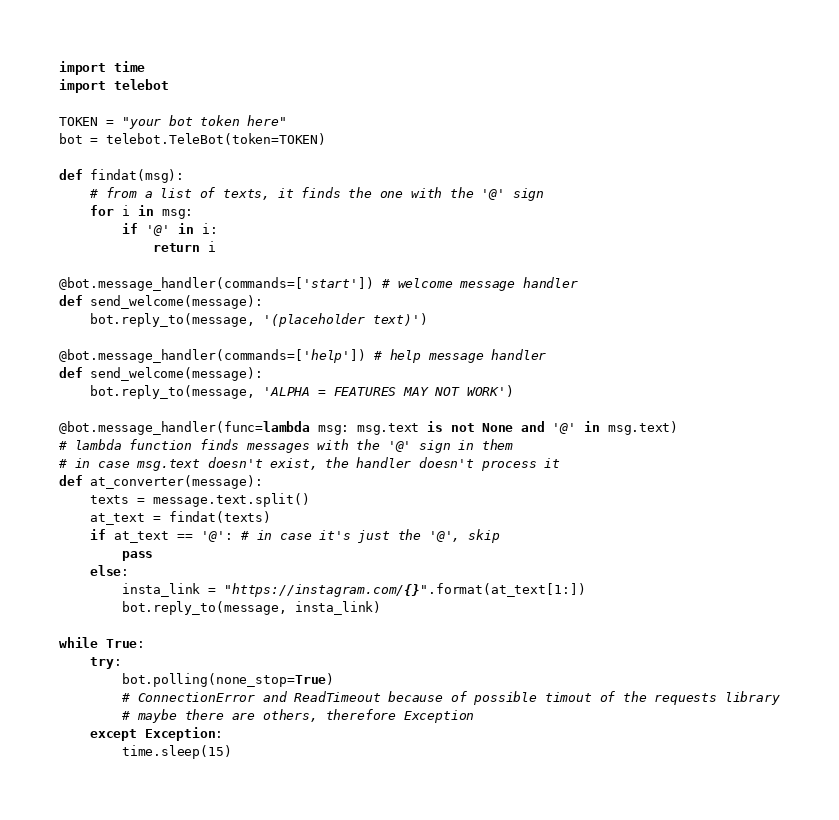<code> <loc_0><loc_0><loc_500><loc_500><_Python_>import time
import telebot

TOKEN = "your bot token here"
bot = telebot.TeleBot(token=TOKEN)

def findat(msg):
    # from a list of texts, it finds the one with the '@' sign
    for i in msg:
        if '@' in i:
            return i

@bot.message_handler(commands=['start']) # welcome message handler
def send_welcome(message):
    bot.reply_to(message, '(placeholder text)')

@bot.message_handler(commands=['help']) # help message handler
def send_welcome(message):
    bot.reply_to(message, 'ALPHA = FEATURES MAY NOT WORK')

@bot.message_handler(func=lambda msg: msg.text is not None and '@' in msg.text)
# lambda function finds messages with the '@' sign in them
# in case msg.text doesn't exist, the handler doesn't process it
def at_converter(message):
    texts = message.text.split()
    at_text = findat(texts)
    if at_text == '@': # in case it's just the '@', skip
        pass
    else:
        insta_link = "https://instagram.com/{}".format(at_text[1:])
        bot.reply_to(message, insta_link)

while True:
    try:
        bot.polling(none_stop=True)
        # ConnectionError and ReadTimeout because of possible timout of the requests library
        # maybe there are others, therefore Exception
    except Exception:
        time.sleep(15)
</code> 